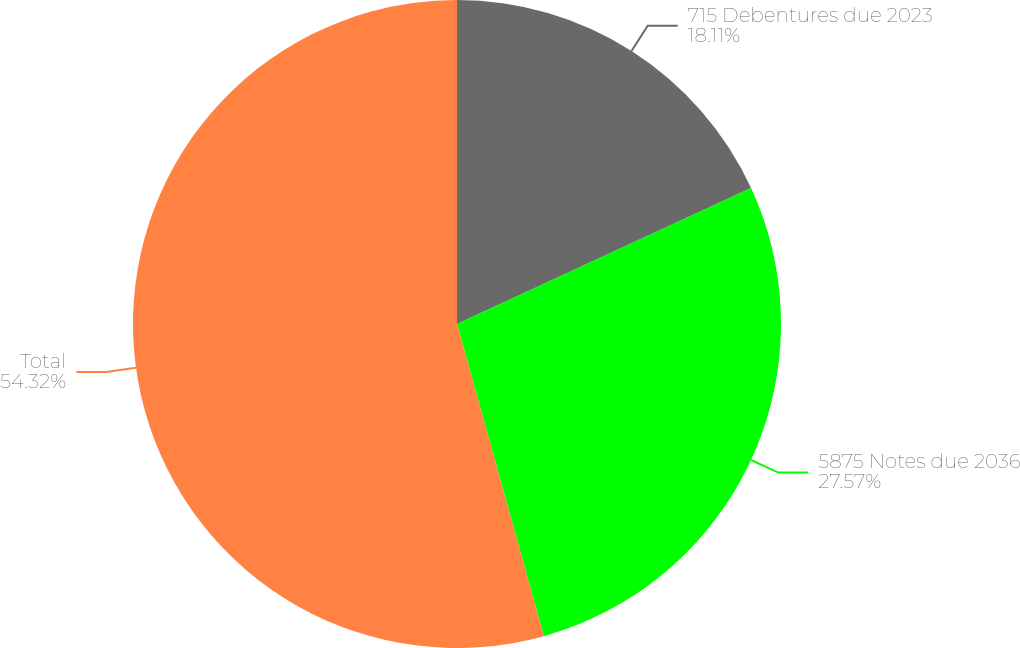Convert chart to OTSL. <chart><loc_0><loc_0><loc_500><loc_500><pie_chart><fcel>715 Debentures due 2023<fcel>5875 Notes due 2036<fcel>Total<nl><fcel>18.11%<fcel>27.57%<fcel>54.32%<nl></chart> 